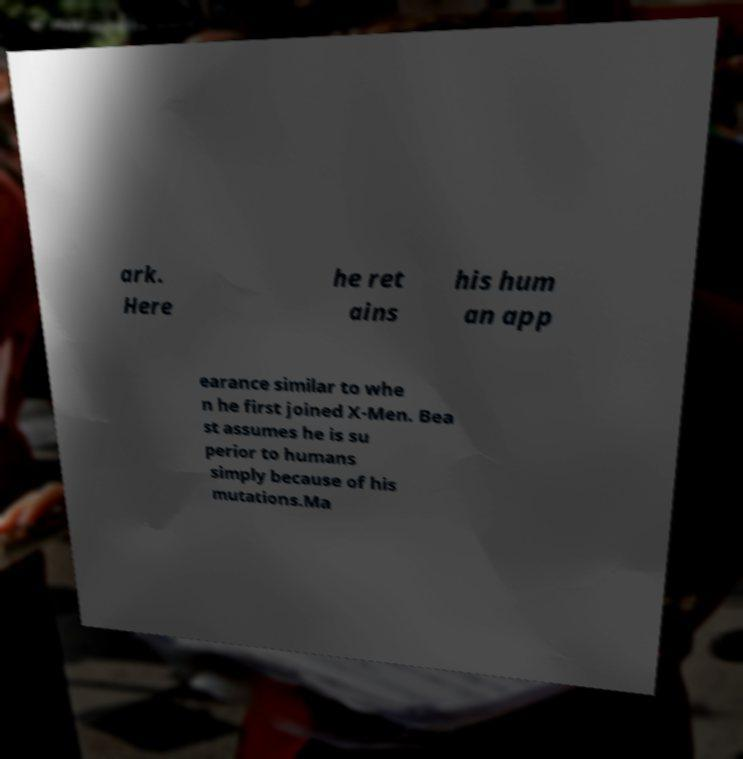There's text embedded in this image that I need extracted. Can you transcribe it verbatim? ark. Here he ret ains his hum an app earance similar to whe n he first joined X-Men. Bea st assumes he is su perior to humans simply because of his mutations.Ma 